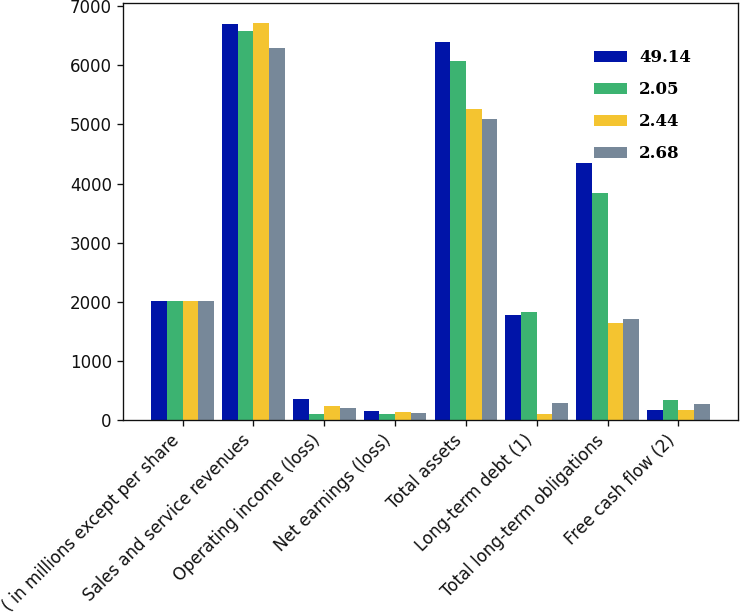Convert chart. <chart><loc_0><loc_0><loc_500><loc_500><stacked_bar_chart><ecel><fcel>( in millions except per share<fcel>Sales and service revenues<fcel>Operating income (loss)<fcel>Net earnings (loss)<fcel>Total assets<fcel>Long-term debt (1)<fcel>Total long-term obligations<fcel>Free cash flow (2)<nl><fcel>49.14<fcel>2012<fcel>6708<fcel>358<fcel>146<fcel>6392<fcel>1779<fcel>4341<fcel>170<nl><fcel>2.05<fcel>2011<fcel>6575<fcel>100<fcel>100<fcel>6069<fcel>1830<fcel>3838<fcel>331<nl><fcel>2.44<fcel>2010<fcel>6723<fcel>241<fcel>131<fcel>5270<fcel>105<fcel>1637<fcel>168<nl><fcel>2.68<fcel>2009<fcel>6292<fcel>203<fcel>119<fcel>5097<fcel>283<fcel>1708<fcel>269<nl></chart> 